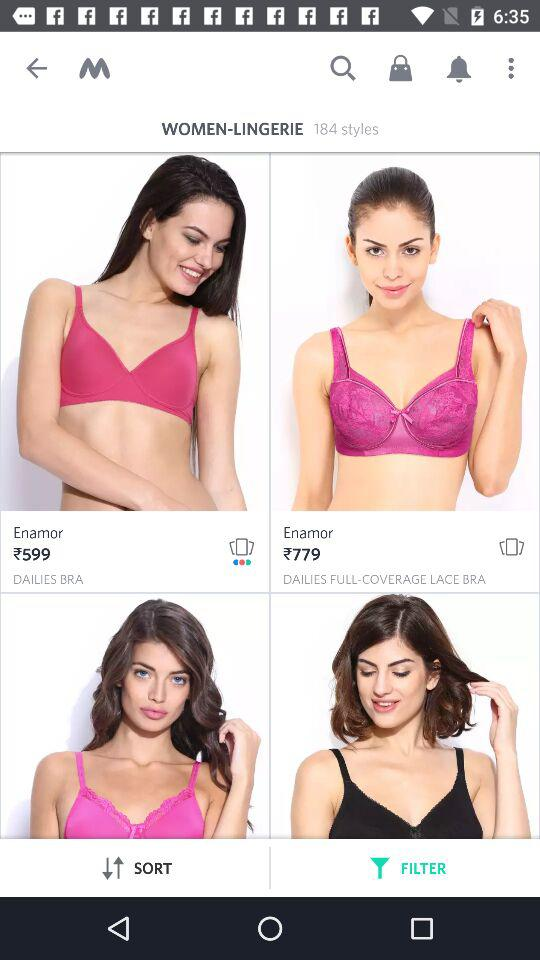What is the price of "DAILIES BRA"? The price is ₹599. 